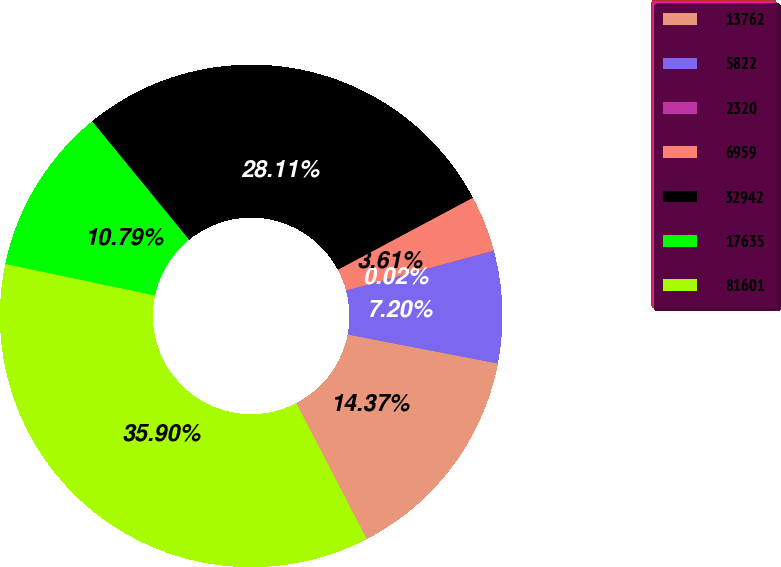Convert chart to OTSL. <chart><loc_0><loc_0><loc_500><loc_500><pie_chart><fcel>13762<fcel>5822<fcel>2320<fcel>6959<fcel>32942<fcel>17635<fcel>81601<nl><fcel>14.37%<fcel>7.2%<fcel>0.02%<fcel>3.61%<fcel>28.11%<fcel>10.79%<fcel>35.9%<nl></chart> 